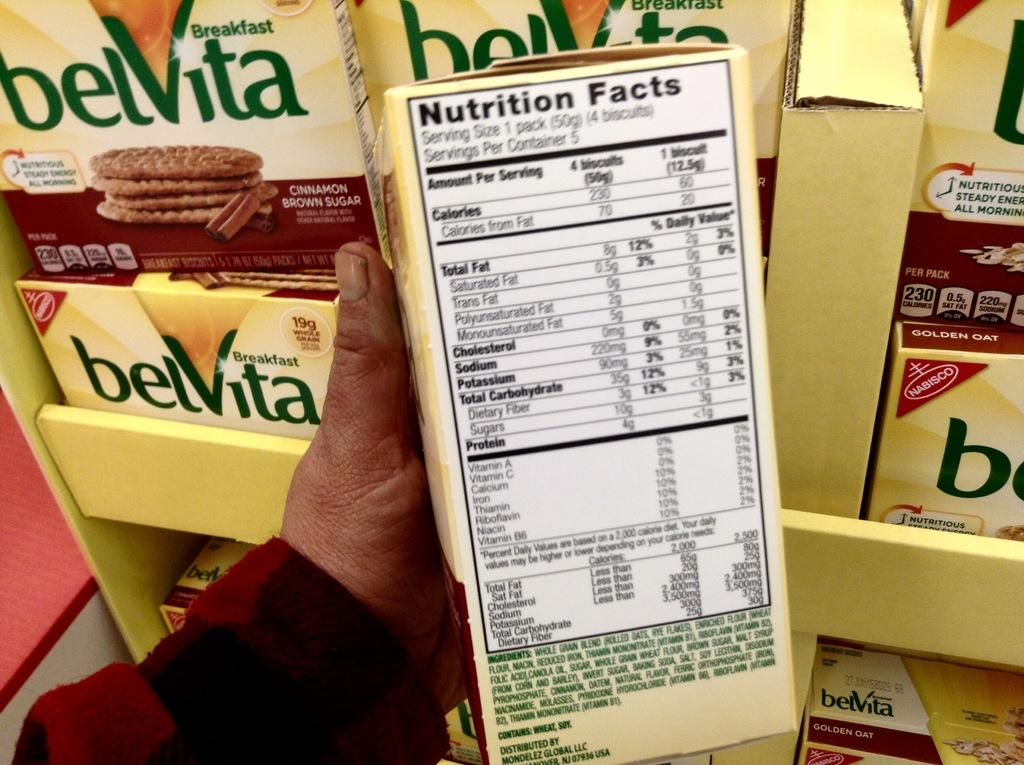<image>
Share a concise interpretation of the image provided. Someone is looking at the Nutrition Facts of Belvita cookies. 